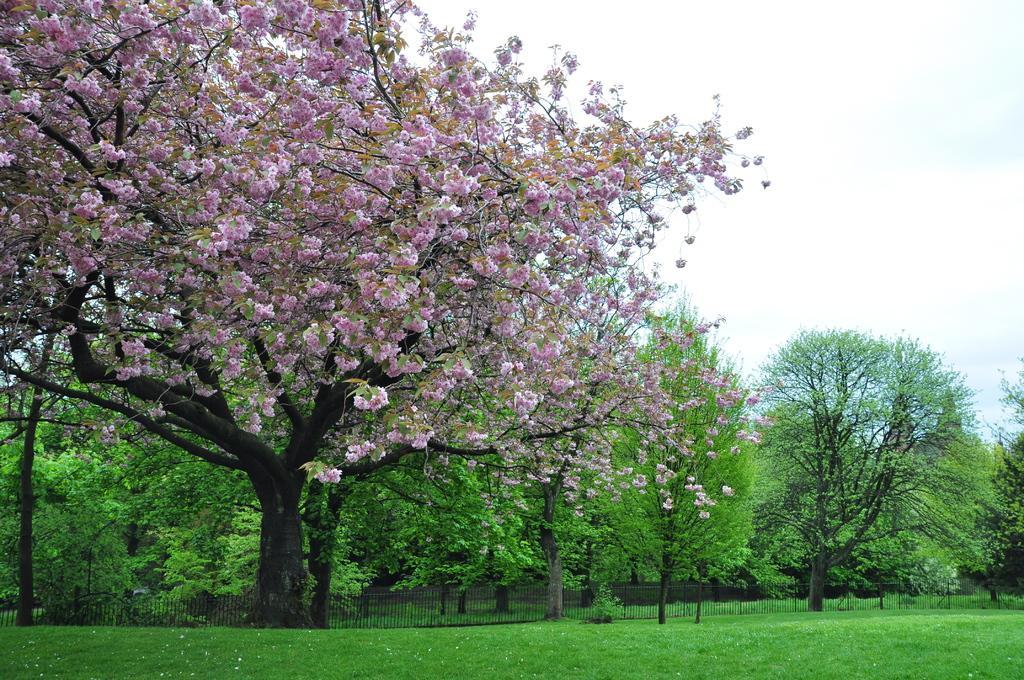Can you describe this image briefly? In this image I can see flowers in purple color, grass and trees in green color, a railing and the sky is in white color. 